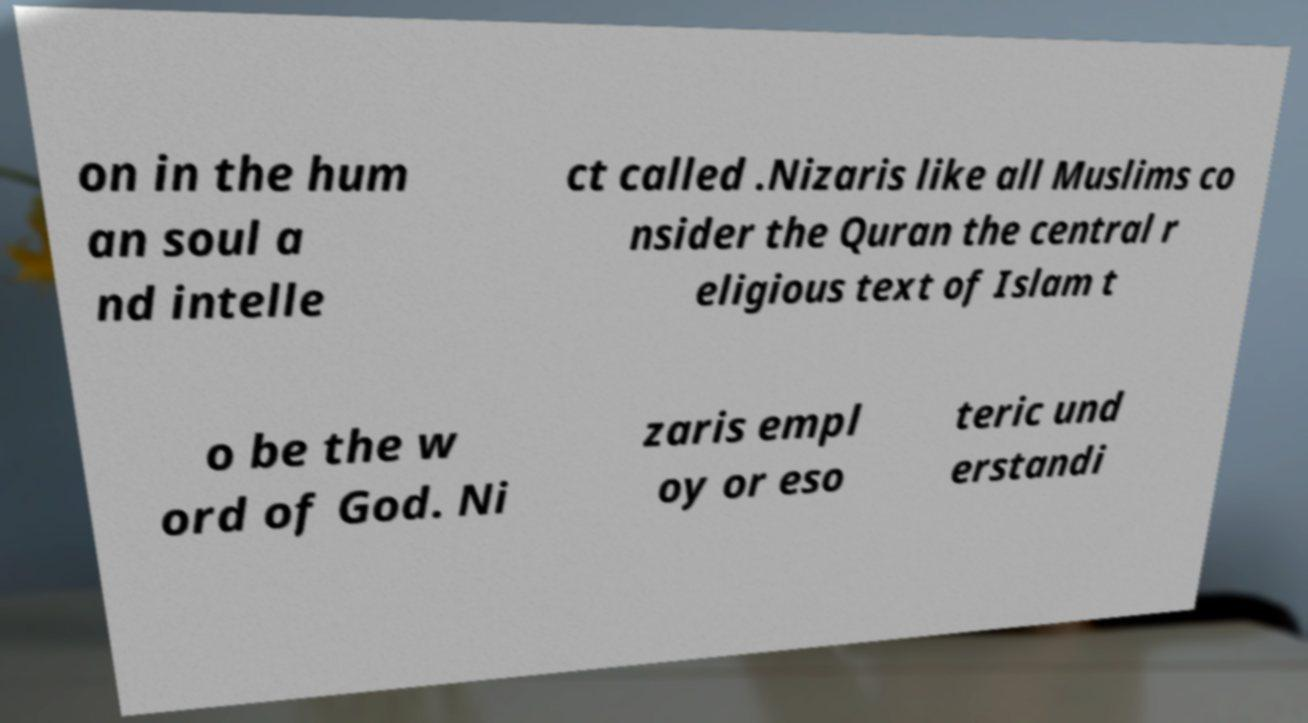I need the written content from this picture converted into text. Can you do that? on in the hum an soul a nd intelle ct called .Nizaris like all Muslims co nsider the Quran the central r eligious text of Islam t o be the w ord of God. Ni zaris empl oy or eso teric und erstandi 